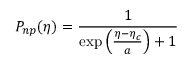<formula> <loc_0><loc_0><loc_500><loc_500>P _ { n p } ( \eta ) = \frac { 1 } { \exp \left ( \frac { \eta - \eta _ { c } } { a } \right ) + 1 }</formula> 